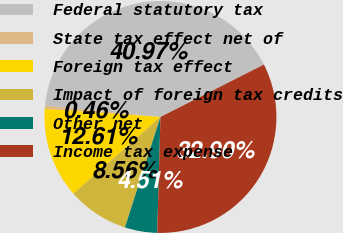<chart> <loc_0><loc_0><loc_500><loc_500><pie_chart><fcel>Federal statutory tax<fcel>State tax effect net of<fcel>Foreign tax effect<fcel>Impact of foreign tax credits<fcel>Other net<fcel>Income tax expense<nl><fcel>40.97%<fcel>0.46%<fcel>12.61%<fcel>8.56%<fcel>4.51%<fcel>32.9%<nl></chart> 